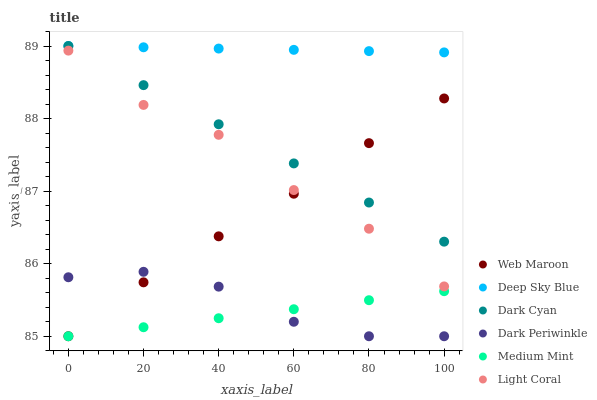Does Medium Mint have the minimum area under the curve?
Answer yes or no. Yes. Does Deep Sky Blue have the maximum area under the curve?
Answer yes or no. Yes. Does Web Maroon have the minimum area under the curve?
Answer yes or no. No. Does Web Maroon have the maximum area under the curve?
Answer yes or no. No. Is Dark Cyan the smoothest?
Answer yes or no. Yes. Is Light Coral the roughest?
Answer yes or no. Yes. Is Web Maroon the smoothest?
Answer yes or no. No. Is Web Maroon the roughest?
Answer yes or no. No. Does Medium Mint have the lowest value?
Answer yes or no. Yes. Does Light Coral have the lowest value?
Answer yes or no. No. Does Dark Cyan have the highest value?
Answer yes or no. Yes. Does Web Maroon have the highest value?
Answer yes or no. No. Is Dark Periwinkle less than Light Coral?
Answer yes or no. Yes. Is Dark Cyan greater than Medium Mint?
Answer yes or no. Yes. Does Web Maroon intersect Dark Periwinkle?
Answer yes or no. Yes. Is Web Maroon less than Dark Periwinkle?
Answer yes or no. No. Is Web Maroon greater than Dark Periwinkle?
Answer yes or no. No. Does Dark Periwinkle intersect Light Coral?
Answer yes or no. No. 